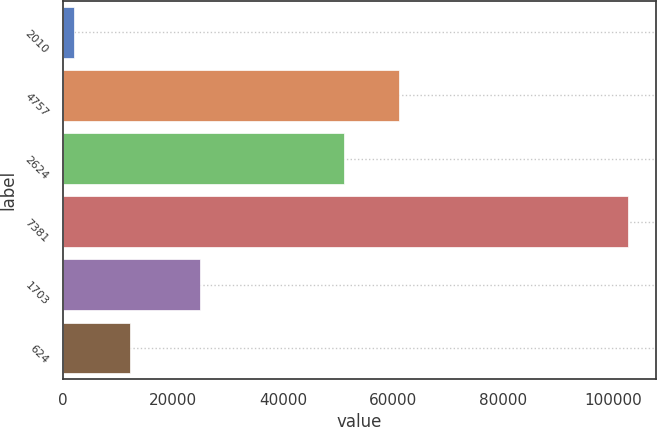<chart> <loc_0><loc_0><loc_500><loc_500><bar_chart><fcel>2010<fcel>4757<fcel>2624<fcel>7381<fcel>1703<fcel>624<nl><fcel>2010<fcel>61069.4<fcel>51001<fcel>102694<fcel>24859<fcel>12078.4<nl></chart> 